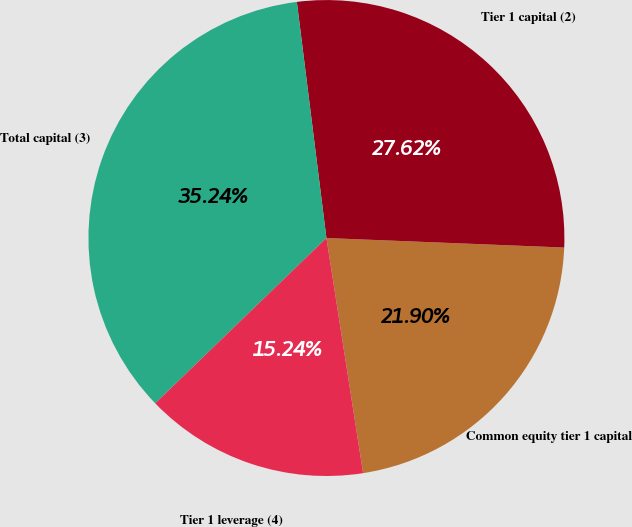Convert chart to OTSL. <chart><loc_0><loc_0><loc_500><loc_500><pie_chart><fcel>Common equity tier 1 capital<fcel>Tier 1 capital (2)<fcel>Total capital (3)<fcel>Tier 1 leverage (4)<nl><fcel>21.9%<fcel>27.62%<fcel>35.24%<fcel>15.24%<nl></chart> 